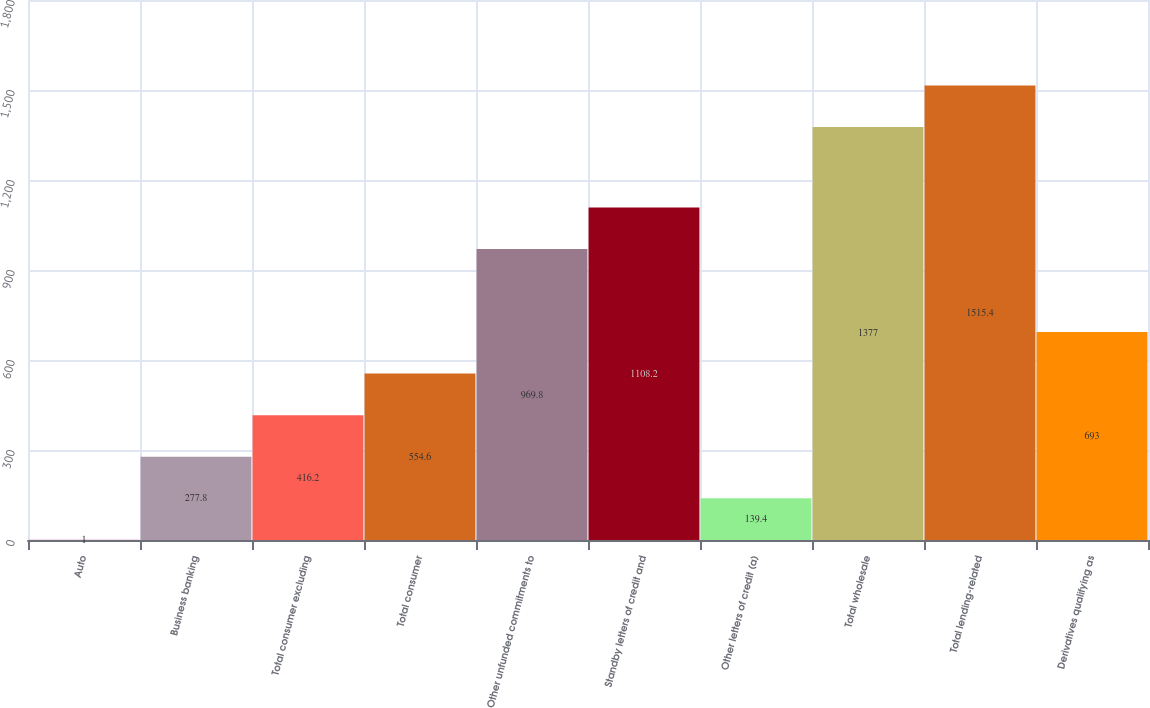<chart> <loc_0><loc_0><loc_500><loc_500><bar_chart><fcel>Auto<fcel>Business banking<fcel>Total consumer excluding<fcel>Total consumer<fcel>Other unfunded commitments to<fcel>Standby letters of credit and<fcel>Other letters of credit (a)<fcel>Total wholesale<fcel>Total lending-related<fcel>Derivatives qualifying as<nl><fcel>1<fcel>277.8<fcel>416.2<fcel>554.6<fcel>969.8<fcel>1108.2<fcel>139.4<fcel>1377<fcel>1515.4<fcel>693<nl></chart> 